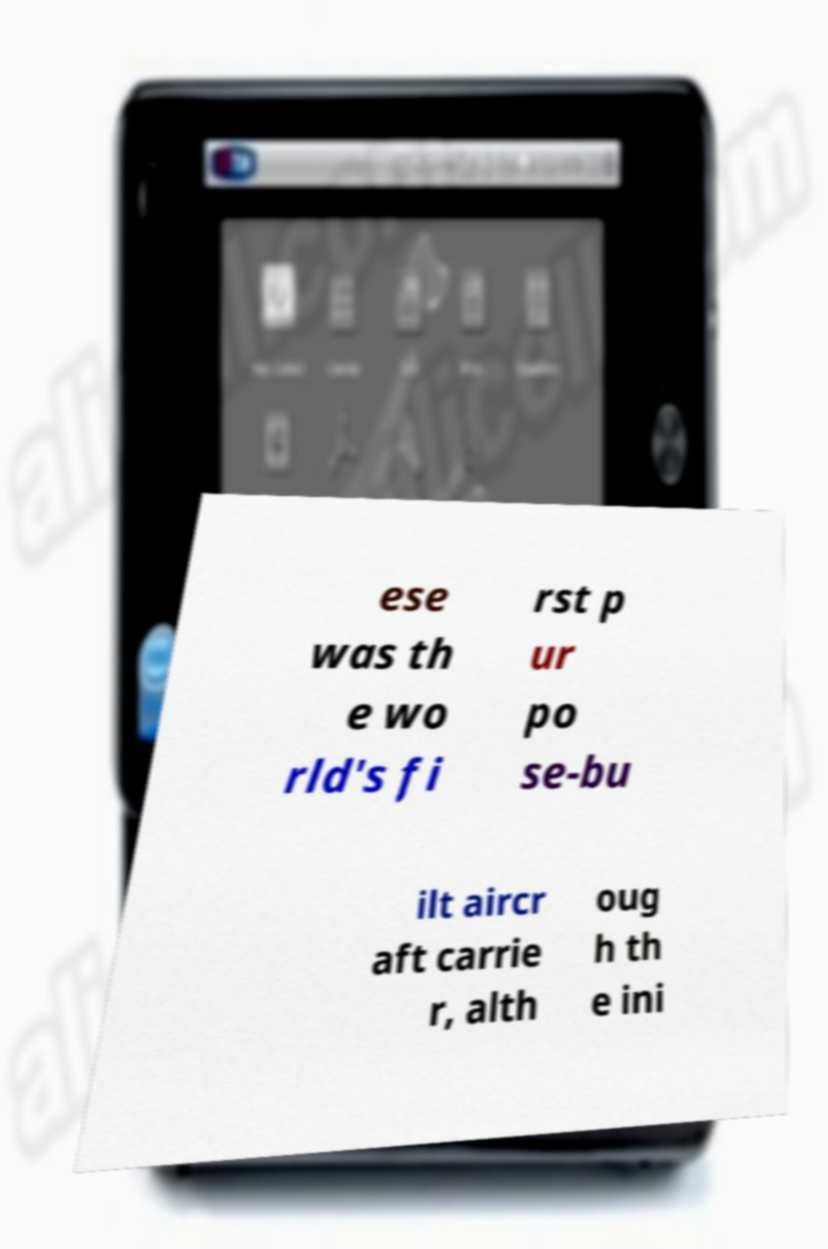Can you read and provide the text displayed in the image?This photo seems to have some interesting text. Can you extract and type it out for me? ese was th e wo rld's fi rst p ur po se-bu ilt aircr aft carrie r, alth oug h th e ini 